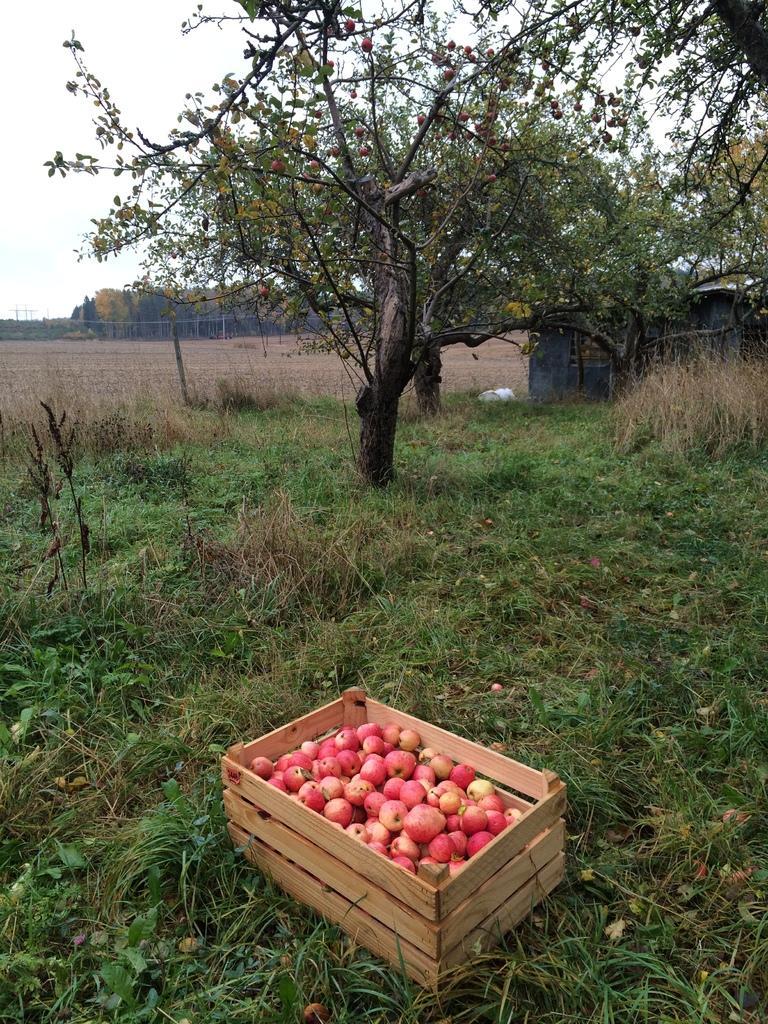Please provide a concise description of this image. In the foreground of the image there is a box with fruits. At the bottom of the image there is grass. In the background of the image there are trees. There is sky. 